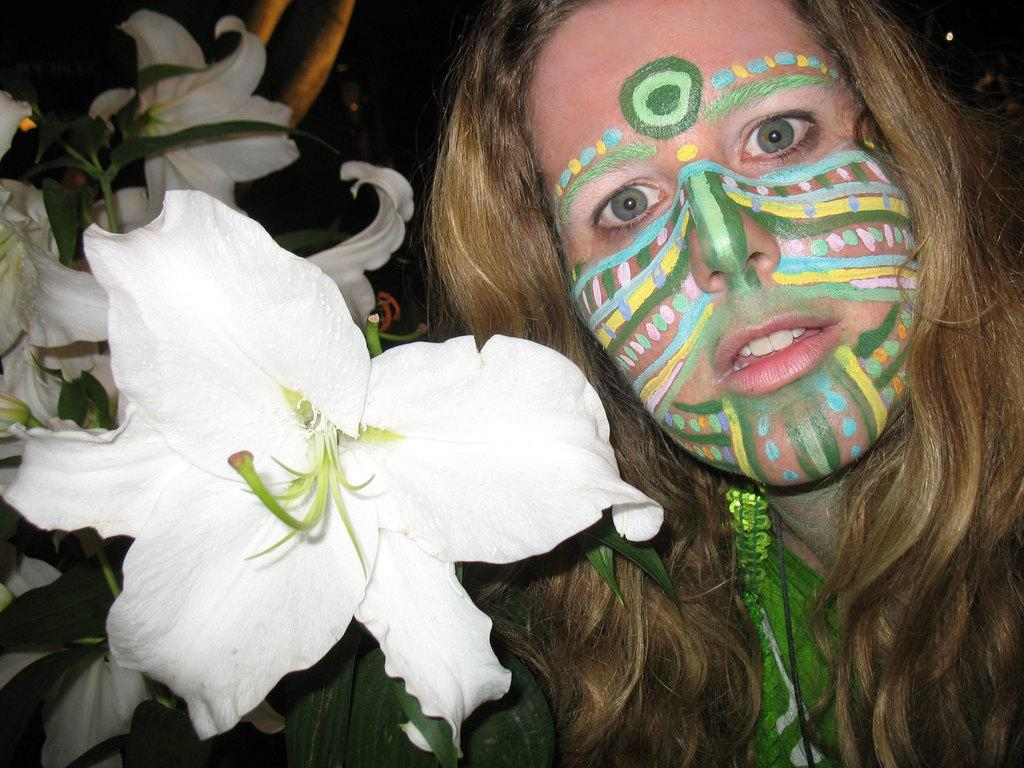Who or what is present in the image? There is a person in the image. What can be seen in the image besides the person? There are flowers in the image. What can be seen behind the person and flowers? There is a background visible in the image. What is located at the top of the image? There are objects on the top of the image. What type of quill is being used by the person in the image? There is no quill present in the image. What is the person cooking on the pan in the image? There is no pan or cooking activity present in the image. 